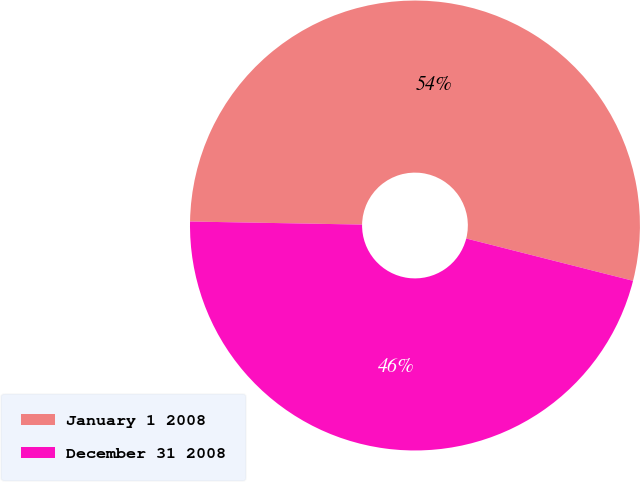Convert chart. <chart><loc_0><loc_0><loc_500><loc_500><pie_chart><fcel>January 1 2008<fcel>December 31 2008<nl><fcel>53.67%<fcel>46.33%<nl></chart> 